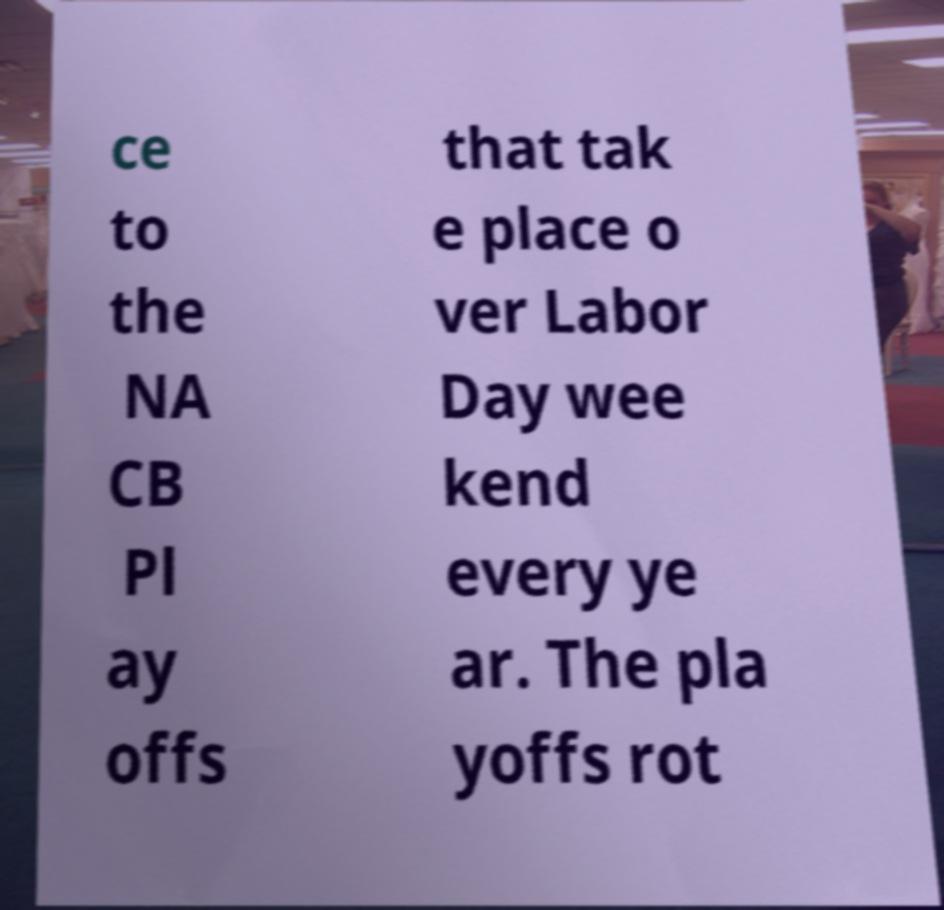Could you assist in decoding the text presented in this image and type it out clearly? ce to the NA CB Pl ay offs that tak e place o ver Labor Day wee kend every ye ar. The pla yoffs rot 